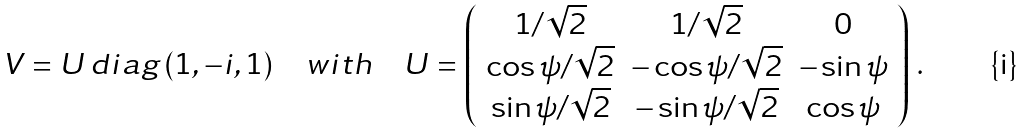Convert formula to latex. <formula><loc_0><loc_0><loc_500><loc_500>V = U \, d i a g \, ( 1 , - i , 1 ) \quad w i t h \quad U = \left ( \begin{array} { c c c } 1 / \sqrt { 2 } & 1 / \sqrt { 2 } & 0 \\ \cos \psi / \sqrt { 2 } & - \cos \psi / \sqrt { 2 } & - \sin \psi \\ \sin \psi / \sqrt { 2 } & - \sin \psi / \sqrt { 2 } & \cos \psi \end{array} \right ) \, .</formula> 